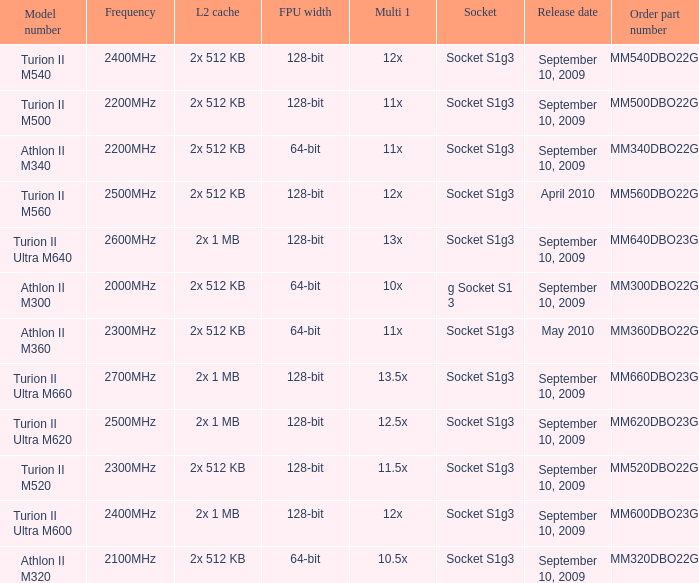What is the release date of the 2x 512 kb L2 cache with a 11x multi 1, and a FPU width of 128-bit? September 10, 2009. Can you give me this table as a dict? {'header': ['Model number', 'Frequency', 'L2 cache', 'FPU width', 'Multi 1', 'Socket', 'Release date', 'Order part number'], 'rows': [['Turion II M540', '2400MHz', '2x 512 KB', '128-bit', '12x', 'Socket S1g3', 'September 10, 2009', 'TMM540DBO22GQ'], ['Turion II M500', '2200MHz', '2x 512 KB', '128-bit', '11x', 'Socket S1g3', 'September 10, 2009', 'TMM500DBO22GQ'], ['Athlon II M340', '2200MHz', '2x 512 KB', '64-bit', '11x', 'Socket S1g3', 'September 10, 2009', 'AMM340DBO22GQ'], ['Turion II M560', '2500MHz', '2x 512 KB', '128-bit', '12x', 'Socket S1g3', 'April 2010', 'TMM560DBO22GQ'], ['Turion II Ultra M640', '2600MHz', '2x 1 MB', '128-bit', '13x', 'Socket S1g3', 'September 10, 2009', 'TMM640DBO23GQ'], ['Athlon II M300', '2000MHz', '2x 512 KB', '64-bit', '10x', 'g Socket S1 3', 'September 10, 2009', 'AMM300DBO22GQ'], ['Athlon II M360', '2300MHz', '2x 512 KB', '64-bit', '11x', 'Socket S1g3', 'May 2010', 'AMM360DBO22GQ'], ['Turion II Ultra M660', '2700MHz', '2x 1 MB', '128-bit', '13.5x', 'Socket S1g3', 'September 10, 2009', 'TMM660DBO23GQ'], ['Turion II Ultra M620', '2500MHz', '2x 1 MB', '128-bit', '12.5x', 'Socket S1g3', 'September 10, 2009', 'TMM620DBO23GQ'], ['Turion II M520', '2300MHz', '2x 512 KB', '128-bit', '11.5x', 'Socket S1g3', 'September 10, 2009', 'TMM520DBO22GQ'], ['Turion II Ultra M600', '2400MHz', '2x 1 MB', '128-bit', '12x', 'Socket S1g3', 'September 10, 2009', 'TMM600DBO23GQ'], ['Athlon II M320', '2100MHz', '2x 512 KB', '64-bit', '10.5x', 'Socket S1g3', 'September 10, 2009', 'AMM320DBO22GQ']]} 